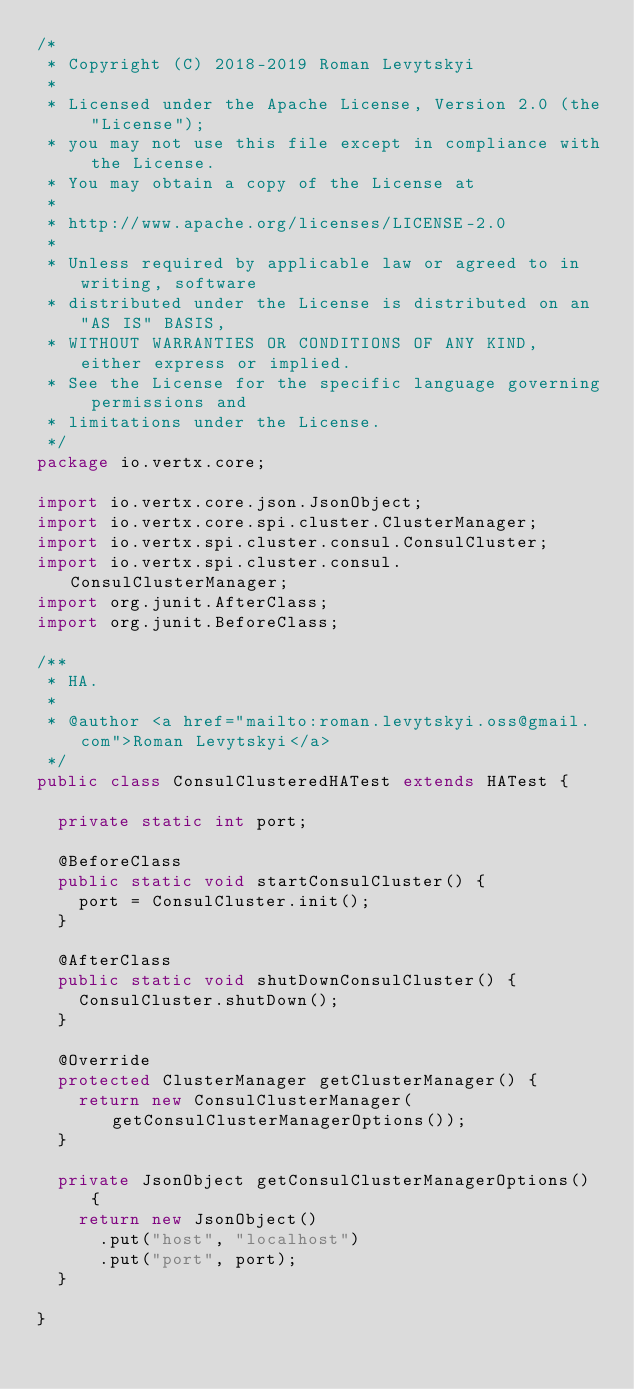<code> <loc_0><loc_0><loc_500><loc_500><_Java_>/*
 * Copyright (C) 2018-2019 Roman Levytskyi
 *
 * Licensed under the Apache License, Version 2.0 (the "License");
 * you may not use this file except in compliance with the License.
 * You may obtain a copy of the License at
 *
 * http://www.apache.org/licenses/LICENSE-2.0
 *
 * Unless required by applicable law or agreed to in writing, software
 * distributed under the License is distributed on an "AS IS" BASIS,
 * WITHOUT WARRANTIES OR CONDITIONS OF ANY KIND, either express or implied.
 * See the License for the specific language governing permissions and
 * limitations under the License.
 */
package io.vertx.core;

import io.vertx.core.json.JsonObject;
import io.vertx.core.spi.cluster.ClusterManager;
import io.vertx.spi.cluster.consul.ConsulCluster;
import io.vertx.spi.cluster.consul.ConsulClusterManager;
import org.junit.AfterClass;
import org.junit.BeforeClass;

/**
 * HA.
 *
 * @author <a href="mailto:roman.levytskyi.oss@gmail.com">Roman Levytskyi</a>
 */
public class ConsulClusteredHATest extends HATest {

  private static int port;

  @BeforeClass
  public static void startConsulCluster() {
    port = ConsulCluster.init();
  }

  @AfterClass
  public static void shutDownConsulCluster() {
    ConsulCluster.shutDown();
  }

  @Override
  protected ClusterManager getClusterManager() {
    return new ConsulClusterManager(getConsulClusterManagerOptions());
  }

  private JsonObject getConsulClusterManagerOptions() {
    return new JsonObject()
      .put("host", "localhost")
      .put("port", port);
  }

}
</code> 